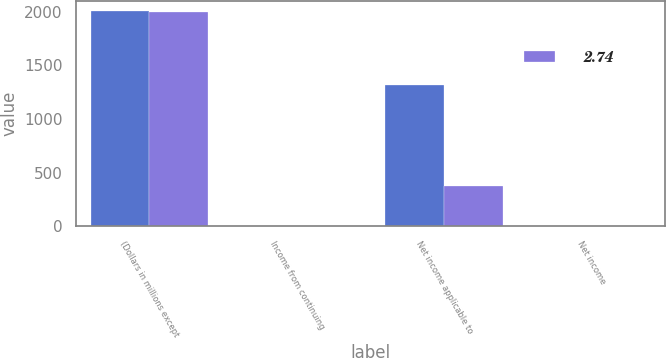Convert chart. <chart><loc_0><loc_0><loc_500><loc_500><stacked_bar_chart><ecel><fcel>(Dollars in millions except<fcel>Income from continuing<fcel>Net income applicable to<fcel>Net income<nl><fcel>nan<fcel>2003<fcel>3.26<fcel>1321<fcel>4.26<nl><fcel>2.74<fcel>2001<fcel>4.54<fcel>377<fcel>1.22<nl></chart> 